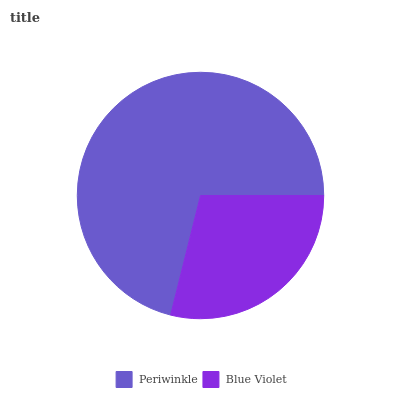Is Blue Violet the minimum?
Answer yes or no. Yes. Is Periwinkle the maximum?
Answer yes or no. Yes. Is Blue Violet the maximum?
Answer yes or no. No. Is Periwinkle greater than Blue Violet?
Answer yes or no. Yes. Is Blue Violet less than Periwinkle?
Answer yes or no. Yes. Is Blue Violet greater than Periwinkle?
Answer yes or no. No. Is Periwinkle less than Blue Violet?
Answer yes or no. No. Is Periwinkle the high median?
Answer yes or no. Yes. Is Blue Violet the low median?
Answer yes or no. Yes. Is Blue Violet the high median?
Answer yes or no. No. Is Periwinkle the low median?
Answer yes or no. No. 